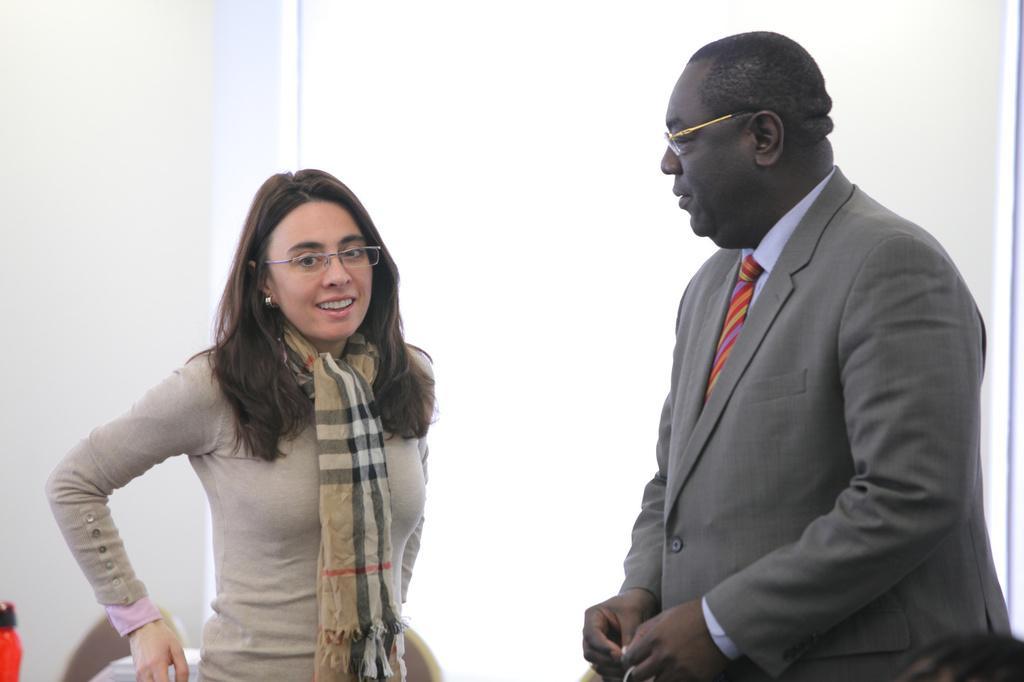In one or two sentences, can you explain what this image depicts? In the center of the image there is a lady wearing a jacket and a scarf around her neck. Beside her there is a person wearing a grey color suit. 